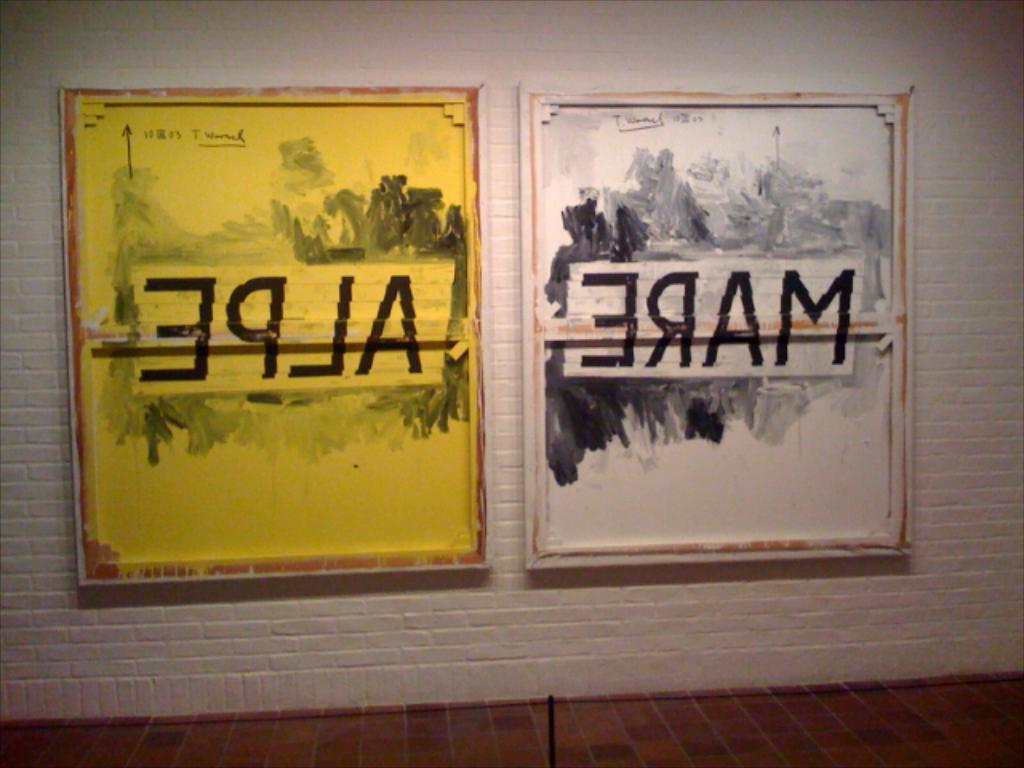<image>
Describe the image concisely. A framed yellow paper labeled Alpe sits next to a framed white paper labeled Mare. 